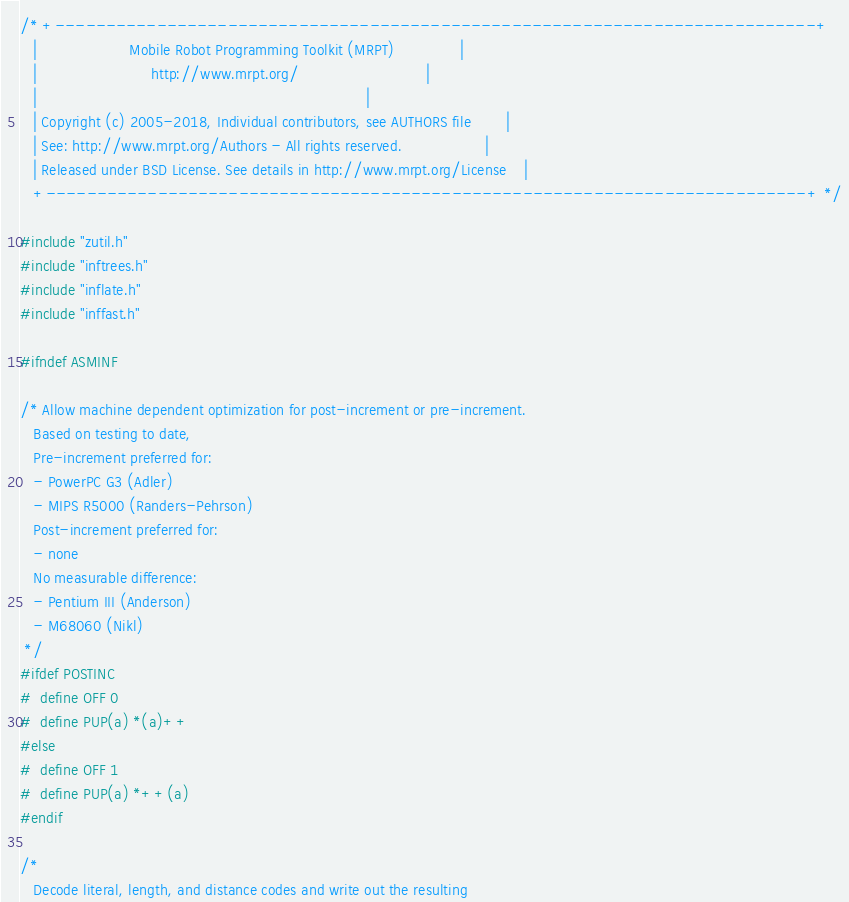Convert code to text. <code><loc_0><loc_0><loc_500><loc_500><_C_>/* +---------------------------------------------------------------------------+
   |                     Mobile Robot Programming Toolkit (MRPT)               |
   |                          http://www.mrpt.org/                             |
   |                                                                           |
   | Copyright (c) 2005-2018, Individual contributors, see AUTHORS file        |
   | See: http://www.mrpt.org/Authors - All rights reserved.                   |
   | Released under BSD License. See details in http://www.mrpt.org/License    |
   +---------------------------------------------------------------------------+ */

#include "zutil.h"
#include "inftrees.h"
#include "inflate.h"
#include "inffast.h"

#ifndef ASMINF

/* Allow machine dependent optimization for post-increment or pre-increment.
   Based on testing to date,
   Pre-increment preferred for:
   - PowerPC G3 (Adler)
   - MIPS R5000 (Randers-Pehrson)
   Post-increment preferred for:
   - none
   No measurable difference:
   - Pentium III (Anderson)
   - M68060 (Nikl)
 */
#ifdef POSTINC
#  define OFF 0
#  define PUP(a) *(a)++
#else
#  define OFF 1
#  define PUP(a) *++(a)
#endif

/*
   Decode literal, length, and distance codes and write out the resulting</code> 